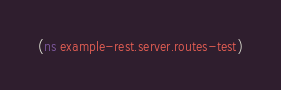Convert code to text. <code><loc_0><loc_0><loc_500><loc_500><_Clojure_>(ns example-rest.server.routes-test)
</code> 